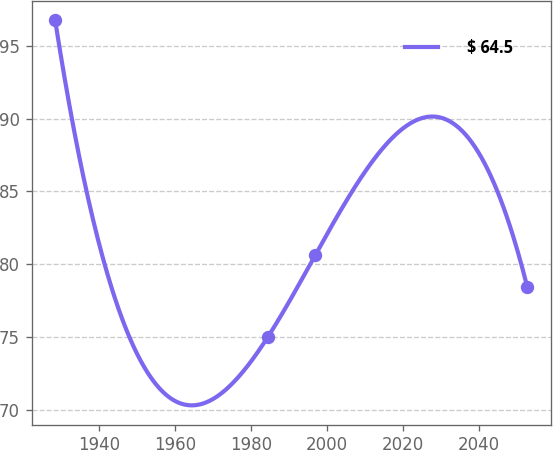Convert chart. <chart><loc_0><loc_0><loc_500><loc_500><line_chart><ecel><fcel>$ 64.5<nl><fcel>1928.53<fcel>96.76<nl><fcel>1984.5<fcel>75.03<nl><fcel>1996.91<fcel>80.62<nl><fcel>2052.68<fcel>78.45<nl></chart> 